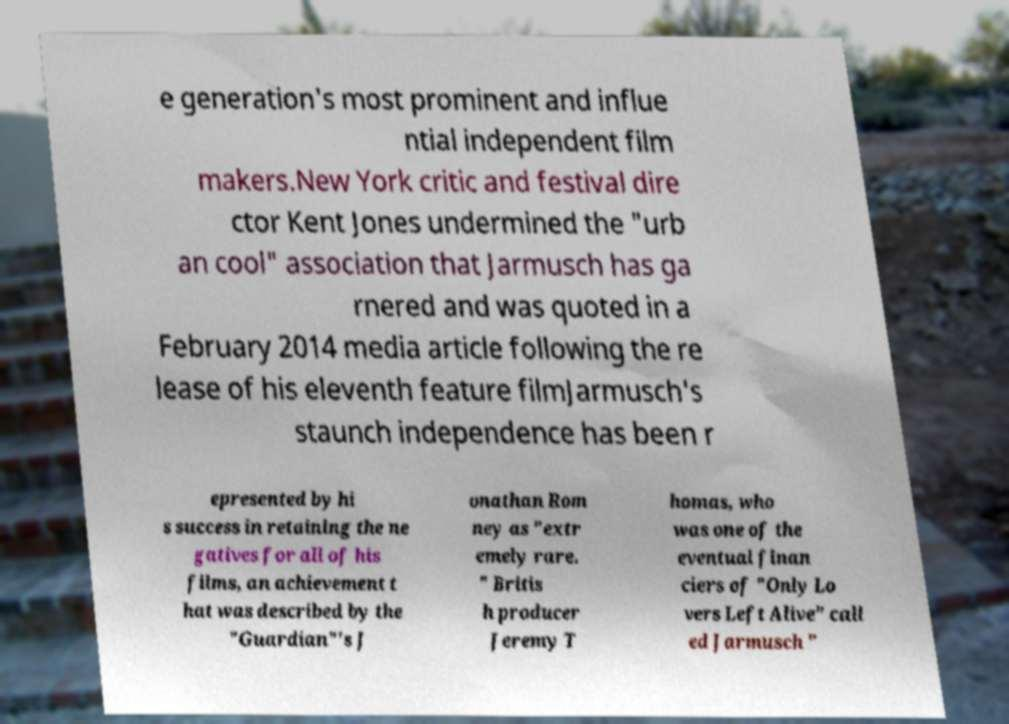Could you extract and type out the text from this image? e generation's most prominent and influe ntial independent film makers.New York critic and festival dire ctor Kent Jones undermined the "urb an cool" association that Jarmusch has ga rnered and was quoted in a February 2014 media article following the re lease of his eleventh feature filmJarmusch's staunch independence has been r epresented by hi s success in retaining the ne gatives for all of his films, an achievement t hat was described by the "Guardian"'s J onathan Rom ney as "extr emely rare. " Britis h producer Jeremy T homas, who was one of the eventual finan ciers of "Only Lo vers Left Alive" call ed Jarmusch " 